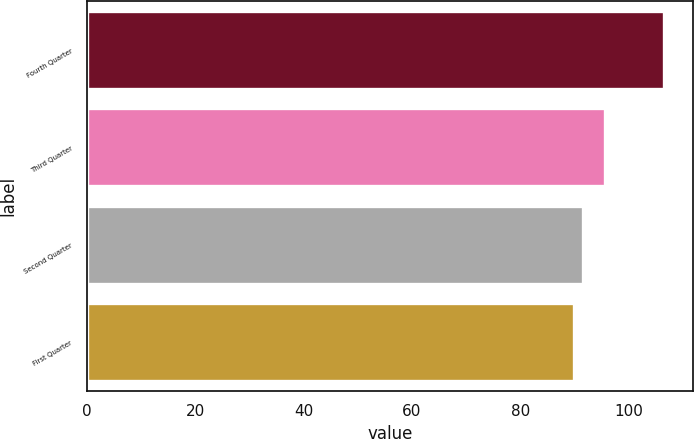Convert chart. <chart><loc_0><loc_0><loc_500><loc_500><bar_chart><fcel>Fourth Quarter<fcel>Third Quarter<fcel>Second Quarter<fcel>First Quarter<nl><fcel>106.46<fcel>95.64<fcel>91.55<fcel>89.89<nl></chart> 